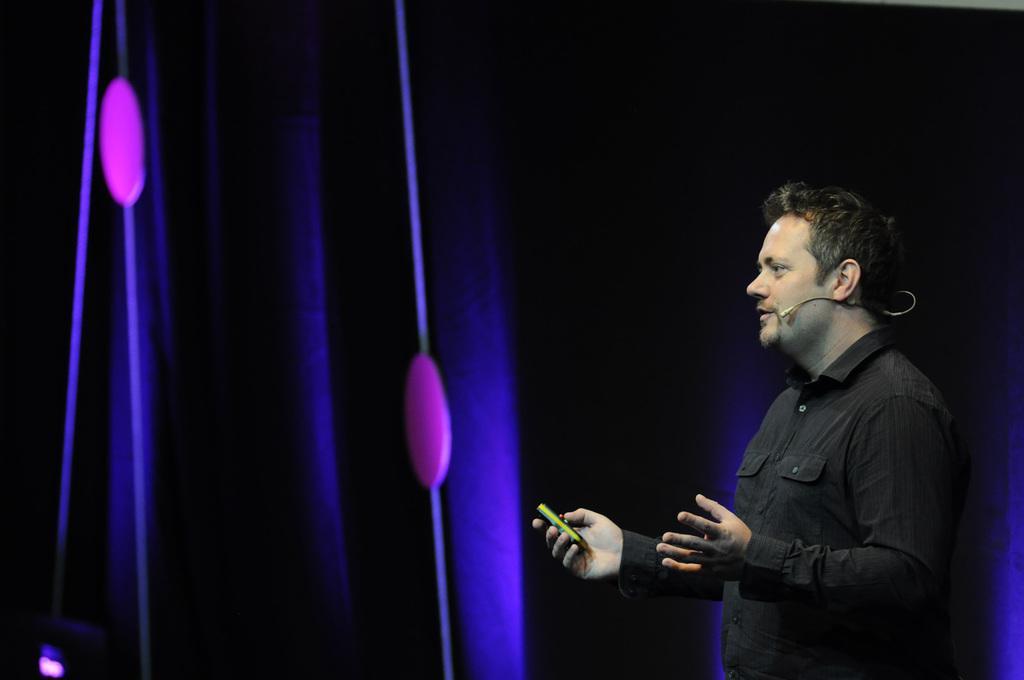Please provide a concise description of this image. In the image there is a man in black t-shirt talking on mic and holding a remote, in the back there are lights on the wall. 